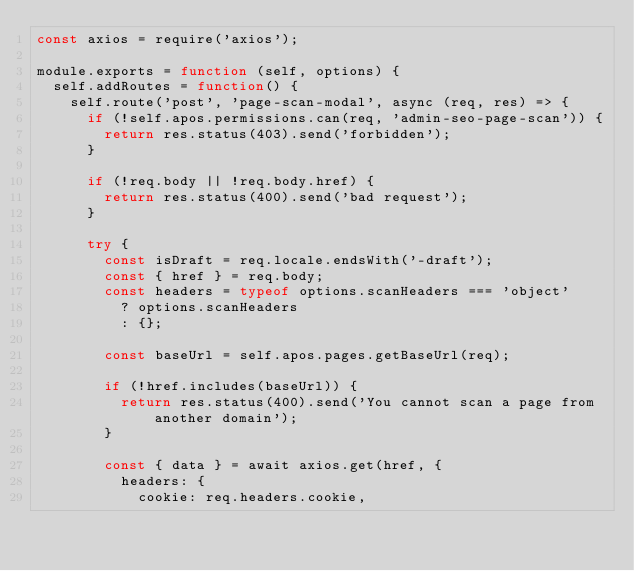Convert code to text. <code><loc_0><loc_0><loc_500><loc_500><_JavaScript_>const axios = require('axios');

module.exports = function (self, options) {
  self.addRoutes = function() {
    self.route('post', 'page-scan-modal', async (req, res) => {
      if (!self.apos.permissions.can(req, 'admin-seo-page-scan')) {
        return res.status(403).send('forbidden');
      }

      if (!req.body || !req.body.href) {
        return res.status(400).send('bad request');
      }

      try {
        const isDraft = req.locale.endsWith('-draft');
        const { href } = req.body;
        const headers = typeof options.scanHeaders === 'object'
          ? options.scanHeaders
          : {};

        const baseUrl = self.apos.pages.getBaseUrl(req);

        if (!href.includes(baseUrl)) {
          return res.status(400).send('You cannot scan a page from another domain');
        }

        const { data } = await axios.get(href, {
          headers: {
            cookie: req.headers.cookie,</code> 